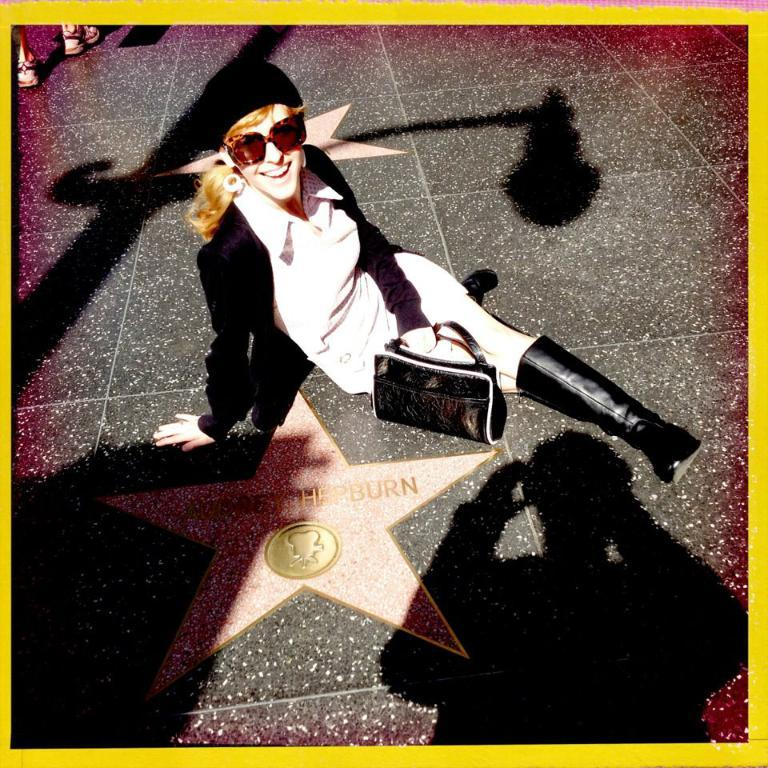Who is present in the image? There is a woman in the image. What is the woman doing in the image? The woman is sitting on the floor. What object does the woman have with her? The woman has a handbag. What is the woman's facial expression in the image? The woman is smiling. What type of shoes is the woman wearing in the image? There is no information about shoes in the image, as the woman is sitting on the floor. 